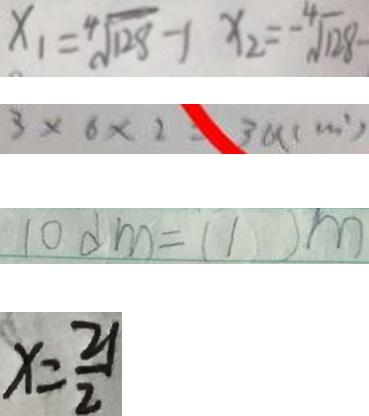<formula> <loc_0><loc_0><loc_500><loc_500>x _ { 1 } = \sqrt [ 4 ] { 1 2 8 } - 1 x _ { 2 } = - \sqrt [ 4 ] { 1 2 8 } - 
 3 \times 6 \times 2 = 3 8 ( c m ^ { 2 } ) 
 1 0 d m = ( 1 ) m 
 x = \frac { 2 1 } { 2 }</formula> 